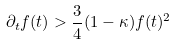Convert formula to latex. <formula><loc_0><loc_0><loc_500><loc_500>\partial _ { t } f ( t ) > \frac { 3 } { 4 } ( 1 - \kappa ) f ( t ) ^ { 2 }</formula> 